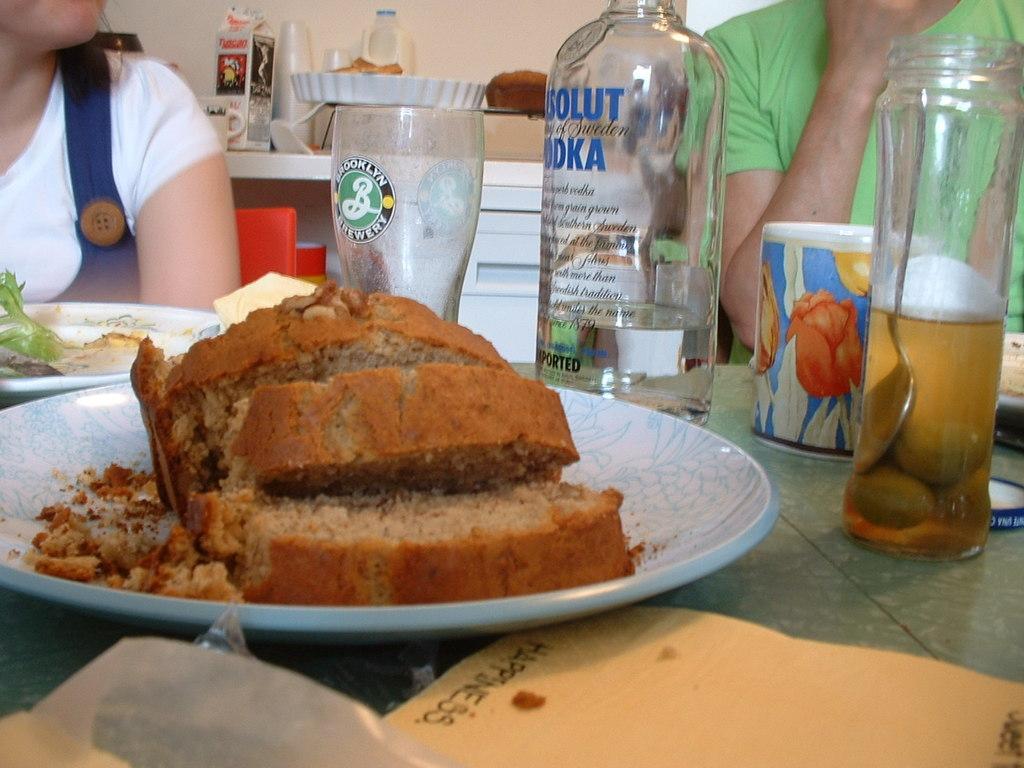Describe this image in one or two sentences. In the image we can see two people wearing clothes. There is a table, on the table there are plates, food on a plate, glass, bottle and a paper. This is a wall and a box. 